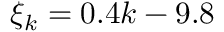<formula> <loc_0><loc_0><loc_500><loc_500>\xi _ { k } = 0 . 4 k - 9 . 8</formula> 